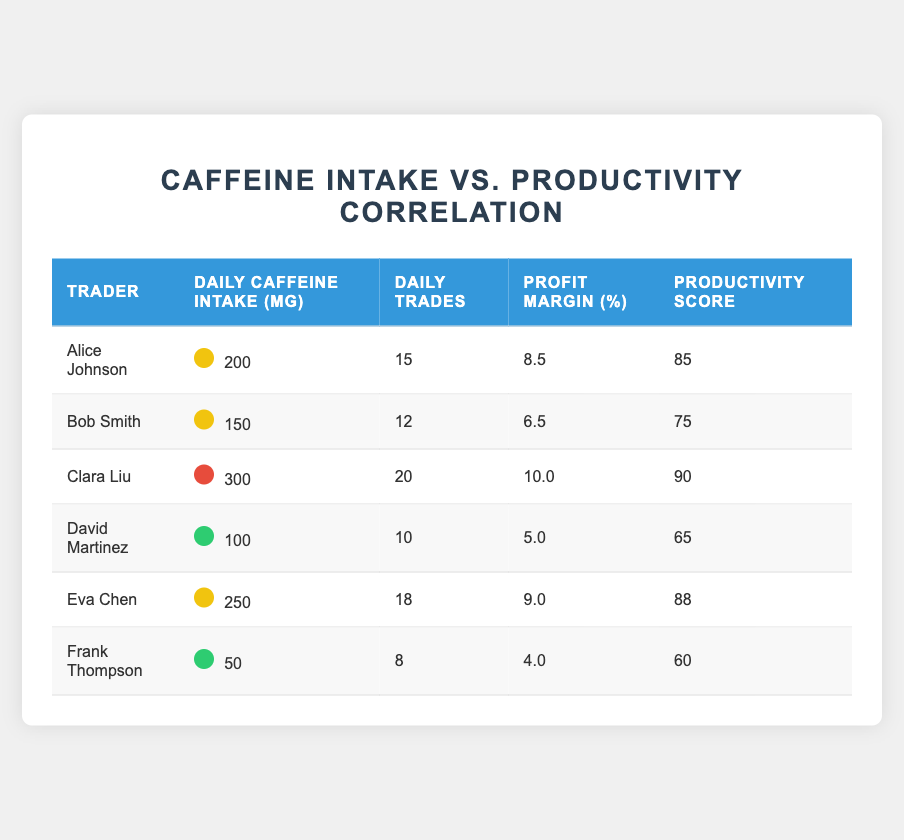What is the daily caffeine intake of Clara Liu? Clara Liu's daily caffeine intake is listed in the table under the corresponding column, which shows a value of 300 mg.
Answer: 300 mg Which trader has the highest productivity score? By reviewing the productivity scores listed for each trader, Clara Liu has the highest score of 90.
Answer: Clara Liu How many daily trades does Alice Johnson make? Alice Johnson’s number of daily trades is directly shown in the table under the daily trades column, which is 15.
Answer: 15 What is the average daily caffeine intake of all traders? To calculate the average, add all the daily caffeine intakes: (200 + 150 + 300 + 100 + 250 + 50) = 1050, then divide by the number of traders, which is 6. So, 1050 / 6 = 175.
Answer: 175 Is Eva Chen’s profit margin percentage greater than that of David Martinez? Eva Chen has a profit margin of 9.0%, while David Martinez has a profit margin of 5.0%. Since 9.0 is greater than 5.0, the statement is true.
Answer: Yes What is the difference in productivity scores between Bob Smith and Frank Thompson? Bob Smith has a productivity score of 75 and Frank Thompson has a score of 60. To find the difference, subtract Frank's score from Bob's: 75 - 60 = 15.
Answer: 15 If the daily caffeine intake increases by 50 mg, how many trades does Clara Liu make? Clara Liu currently has a caffeine intake of 300 mg, and her daily trades are listed as 20 in the table. The question assumes a hypothetical increase but does not change her current trades, which remains 20.
Answer: 20 How many traders have a productivity score of 80 or higher? The traders with scores of 80 or higher are Alice Johnson (85), Clara Liu (90), and Eva Chen (88). This means there are 3 traders meeting the criteria.
Answer: 3 What is the total profit margin percentage of all traders combined? To find the total profit margin percentage, add each trader’s profit margin: (8.5 + 6.5 + 10.0 + 5.0 + 9.0 + 4.0) = 43.0.
Answer: 43.0 